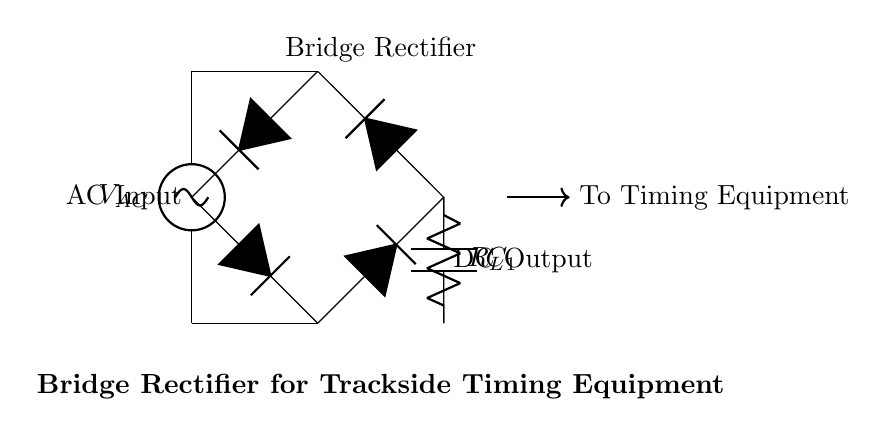What is the type of AC source used in this circuit? The circuit diagram indicates a voltage source represented as "V_AC," which signifies that an alternating current (AC) source is used.
Answer: AC source What is the purpose of the capacitor labeled C_1? The capacitor in this circuit is used for smoothing the output voltage, reducing fluctuations caused by the rectification process. This process minimizes voltage ripple to provide a more stable DC voltage.
Answer: Smoothing What type of rectification is implemented in this circuit? The circuit employs a bridge rectifier configuration, indicated by the arrangement of four diodes connecting the AC input to the DC output. This is a standard method for converting AC to DC.
Answer: Bridge rectification How many diodes are used in this configuration? The circuit diagram displays four diodes in total, arranged in a bridge configuration. Each diode plays a role in directing current during both halves of the AC cycle.
Answer: Four diodes What is the label of the load resistor in this circuit? The resistor is specifically labeled as "R_L," indicating that it is the load resistor connected to the output of the rectifier circuit, which powers the timing equipment.
Answer: R_L What is the voltage output type at the load? The output voltage at the load after rectification is always positive, as the configuration ensures that regardless of the AC input phase, the output is a direct current (DC) supply.
Answer: DC output Why is a bridge rectifier preferred for trackside timing equipment? The bridge rectifier allows full-wave rectification, improving efficiency by utilizing both halves of the AC waveform. This is crucial for time-sensitive applications, such as trackside timing, where stable and reliable power is required.
Answer: Efficiency 